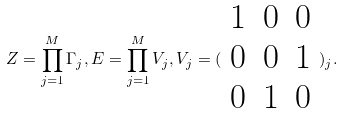Convert formula to latex. <formula><loc_0><loc_0><loc_500><loc_500>Z = \prod _ { j = 1 } ^ { M } \Gamma _ { j } , E = \prod _ { j = 1 } ^ { M } V _ { j } , V _ { j } = ( \begin{array} { c c c } 1 & 0 & 0 \\ 0 & 0 & 1 \\ 0 & 1 & 0 \end{array} ) _ { j } .</formula> 